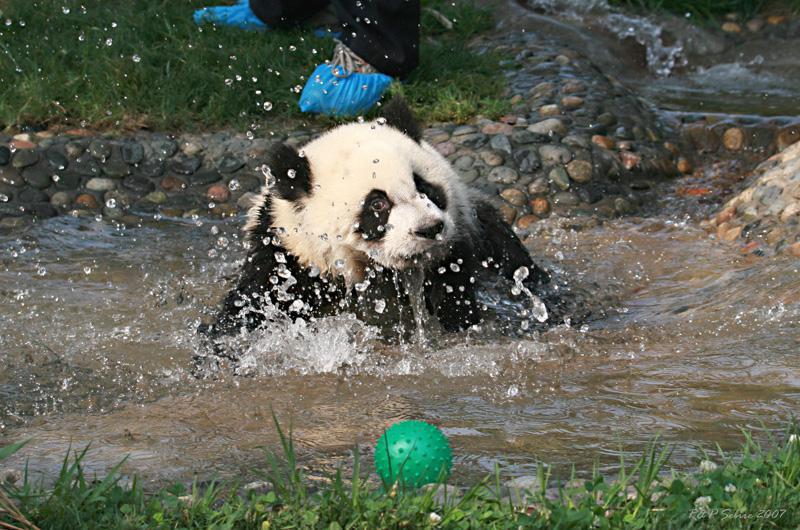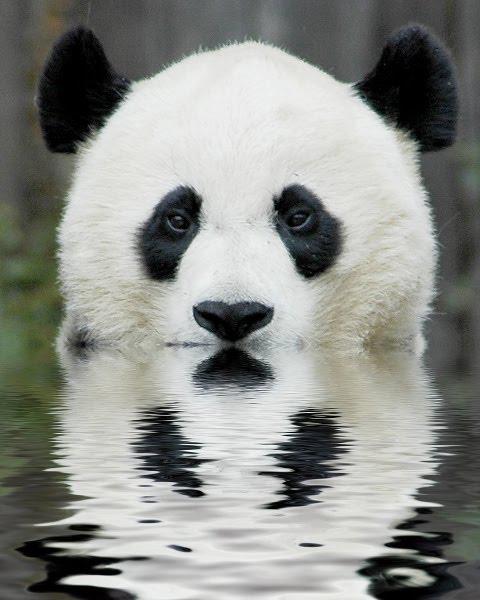The first image is the image on the left, the second image is the image on the right. Given the left and right images, does the statement "A grassy area surrounds a swimming panda in on e of the images." hold true? Answer yes or no. Yes. 